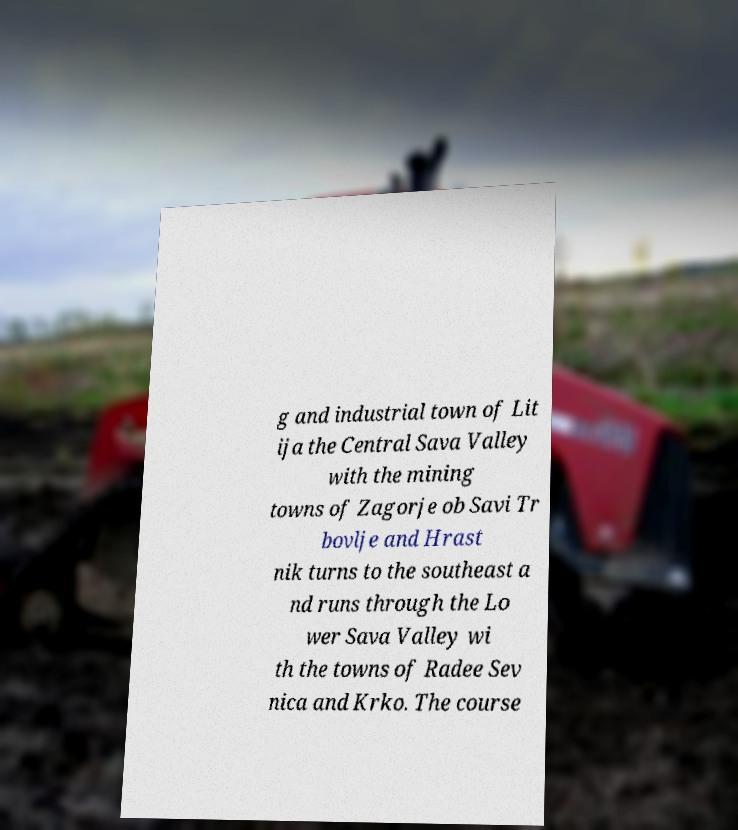What messages or text are displayed in this image? I need them in a readable, typed format. g and industrial town of Lit ija the Central Sava Valley with the mining towns of Zagorje ob Savi Tr bovlje and Hrast nik turns to the southeast a nd runs through the Lo wer Sava Valley wi th the towns of Radee Sev nica and Krko. The course 